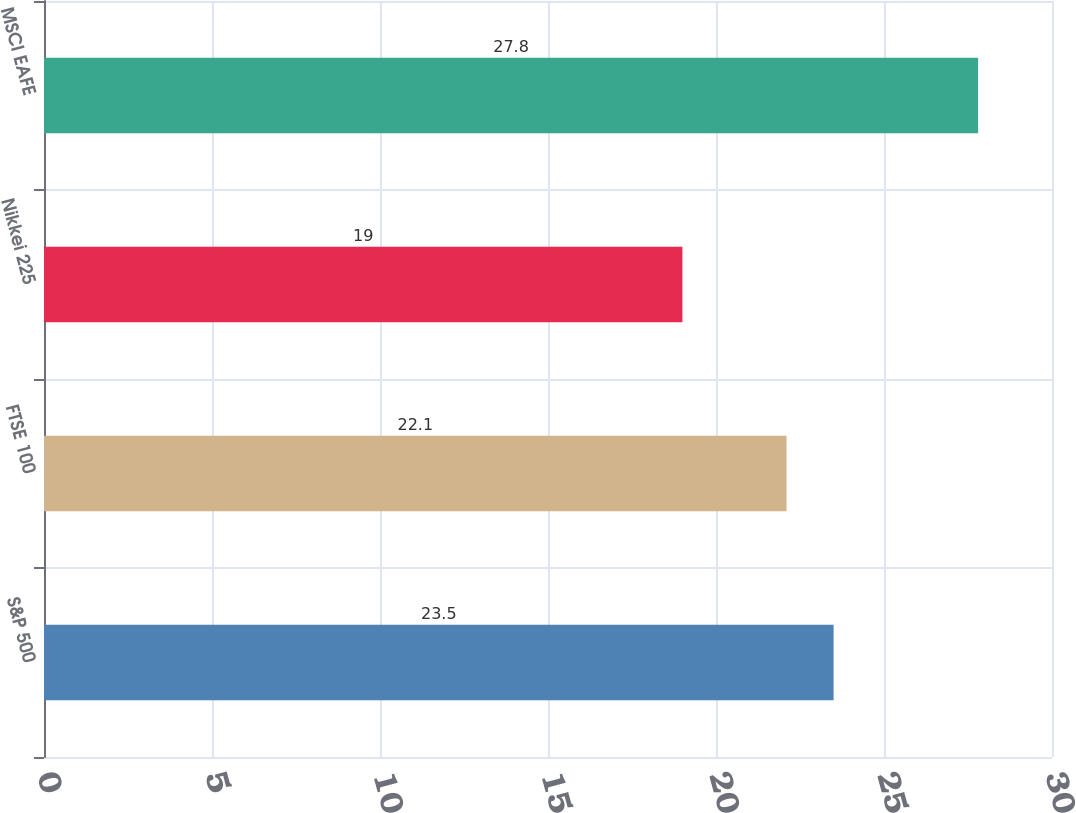Convert chart to OTSL. <chart><loc_0><loc_0><loc_500><loc_500><bar_chart><fcel>S&P 500<fcel>FTSE 100<fcel>Nikkei 225<fcel>MSCI EAFE<nl><fcel>23.5<fcel>22.1<fcel>19<fcel>27.8<nl></chart> 